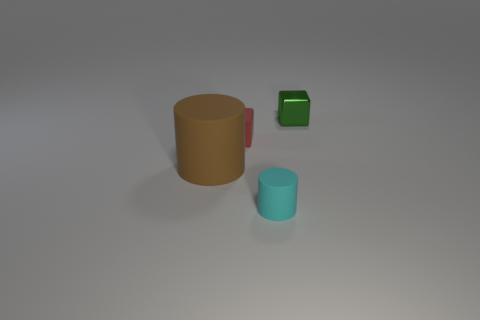Is there any other thing that is made of the same material as the green block?
Keep it short and to the point. No. Do the large brown matte object and the tiny matte thing in front of the large matte cylinder have the same shape?
Give a very brief answer. Yes. There is a large brown rubber thing; are there any small shiny blocks on the right side of it?
Provide a short and direct response. Yes. What number of cylinders are tiny red matte objects or large rubber things?
Give a very brief answer. 1. Is the tiny red object the same shape as the big brown rubber thing?
Ensure brevity in your answer.  No. There is a matte object that is to the left of the small rubber block; how big is it?
Ensure brevity in your answer.  Large. Is the size of the matte thing that is in front of the brown thing the same as the small red object?
Provide a succinct answer. Yes. The small metallic cube is what color?
Provide a succinct answer. Green. The block in front of the tiny block that is behind the small red object is what color?
Your answer should be compact. Red. Is there a purple block that has the same material as the large cylinder?
Provide a short and direct response. No. 